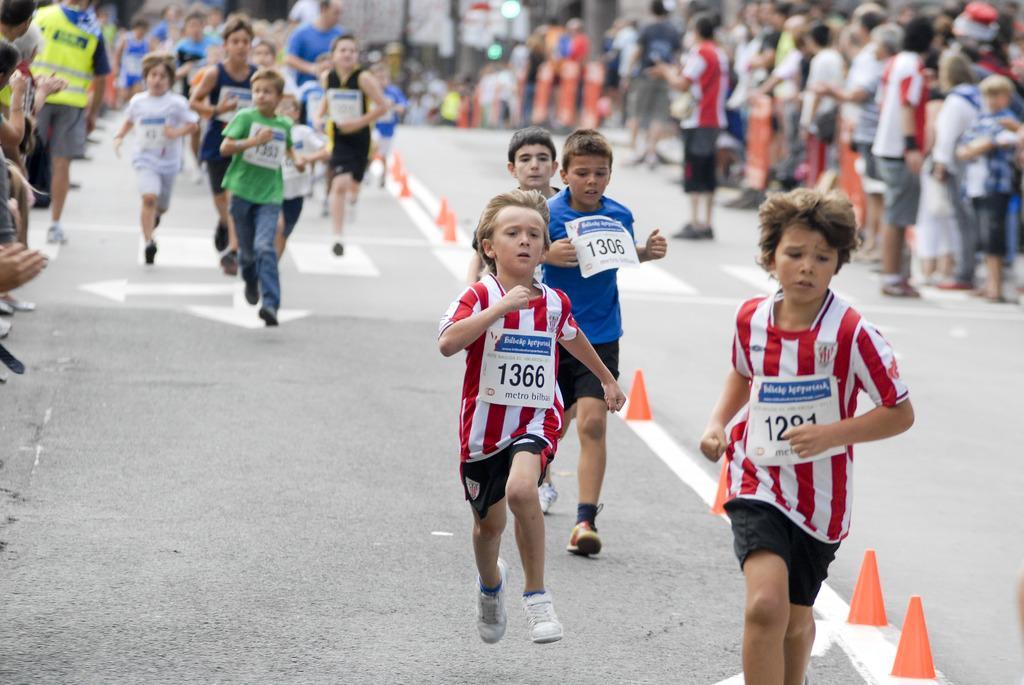Describe this image in one or two sentences. This picture describes about group of people, few kids are running on the road, in the middle of the road we can find few blocks. 